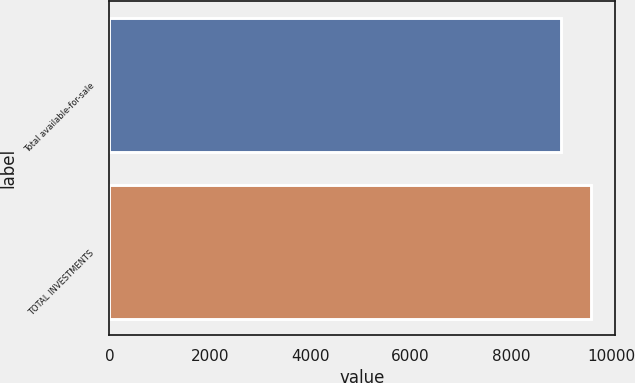Convert chart to OTSL. <chart><loc_0><loc_0><loc_500><loc_500><bar_chart><fcel>Total available-for-sale<fcel>TOTAL INVESTMENTS<nl><fcel>9008<fcel>9597<nl></chart> 